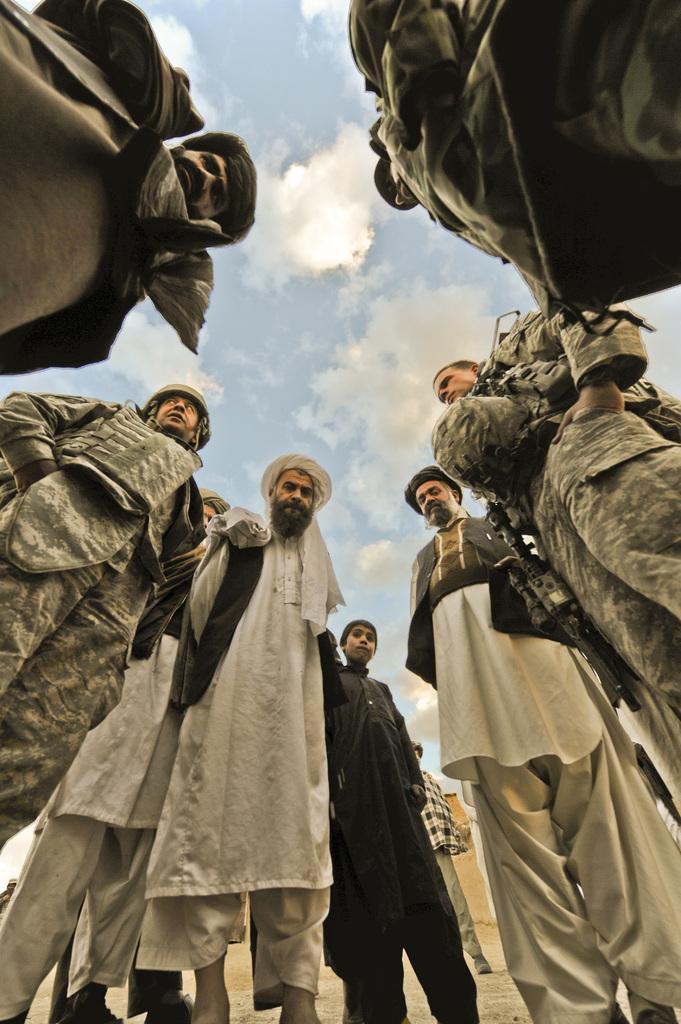Please provide a concise description of this image. In this picture I can see there are a group of people standing here and few are wearing army uniforms and others are wearing long shirts and pants, with head wear. There is soil on the floor and the sky is clear. 